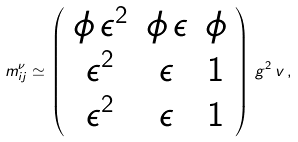Convert formula to latex. <formula><loc_0><loc_0><loc_500><loc_500>m ^ { \nu } _ { i j } \simeq \left ( \begin{array} { c c c } \phi \, \epsilon ^ { 2 } & \phi \, \epsilon & \phi \\ \epsilon ^ { 2 } & \epsilon & 1 \\ \epsilon ^ { 2 } & \epsilon & 1 \\ \end{array} \right ) \, g ^ { 2 } \, v \, ,</formula> 